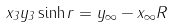<formula> <loc_0><loc_0><loc_500><loc_500>x _ { 3 } y _ { 3 } \sinh r = \| y _ { \infty } - x _ { \infty } \| R</formula> 